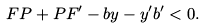Convert formula to latex. <formula><loc_0><loc_0><loc_500><loc_500>F P + P F ^ { \prime } - b y - y ^ { \prime } b ^ { \prime } < 0 .</formula> 